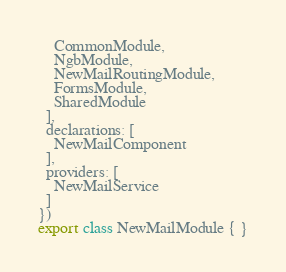<code> <loc_0><loc_0><loc_500><loc_500><_TypeScript_>    CommonModule,
    NgbModule,
    NewMailRoutingModule,
    FormsModule,
    SharedModule
  ],
  declarations: [
    NewMailComponent
  ],
  providers: [
    NewMailService
  ]
})
export class NewMailModule { }
</code> 